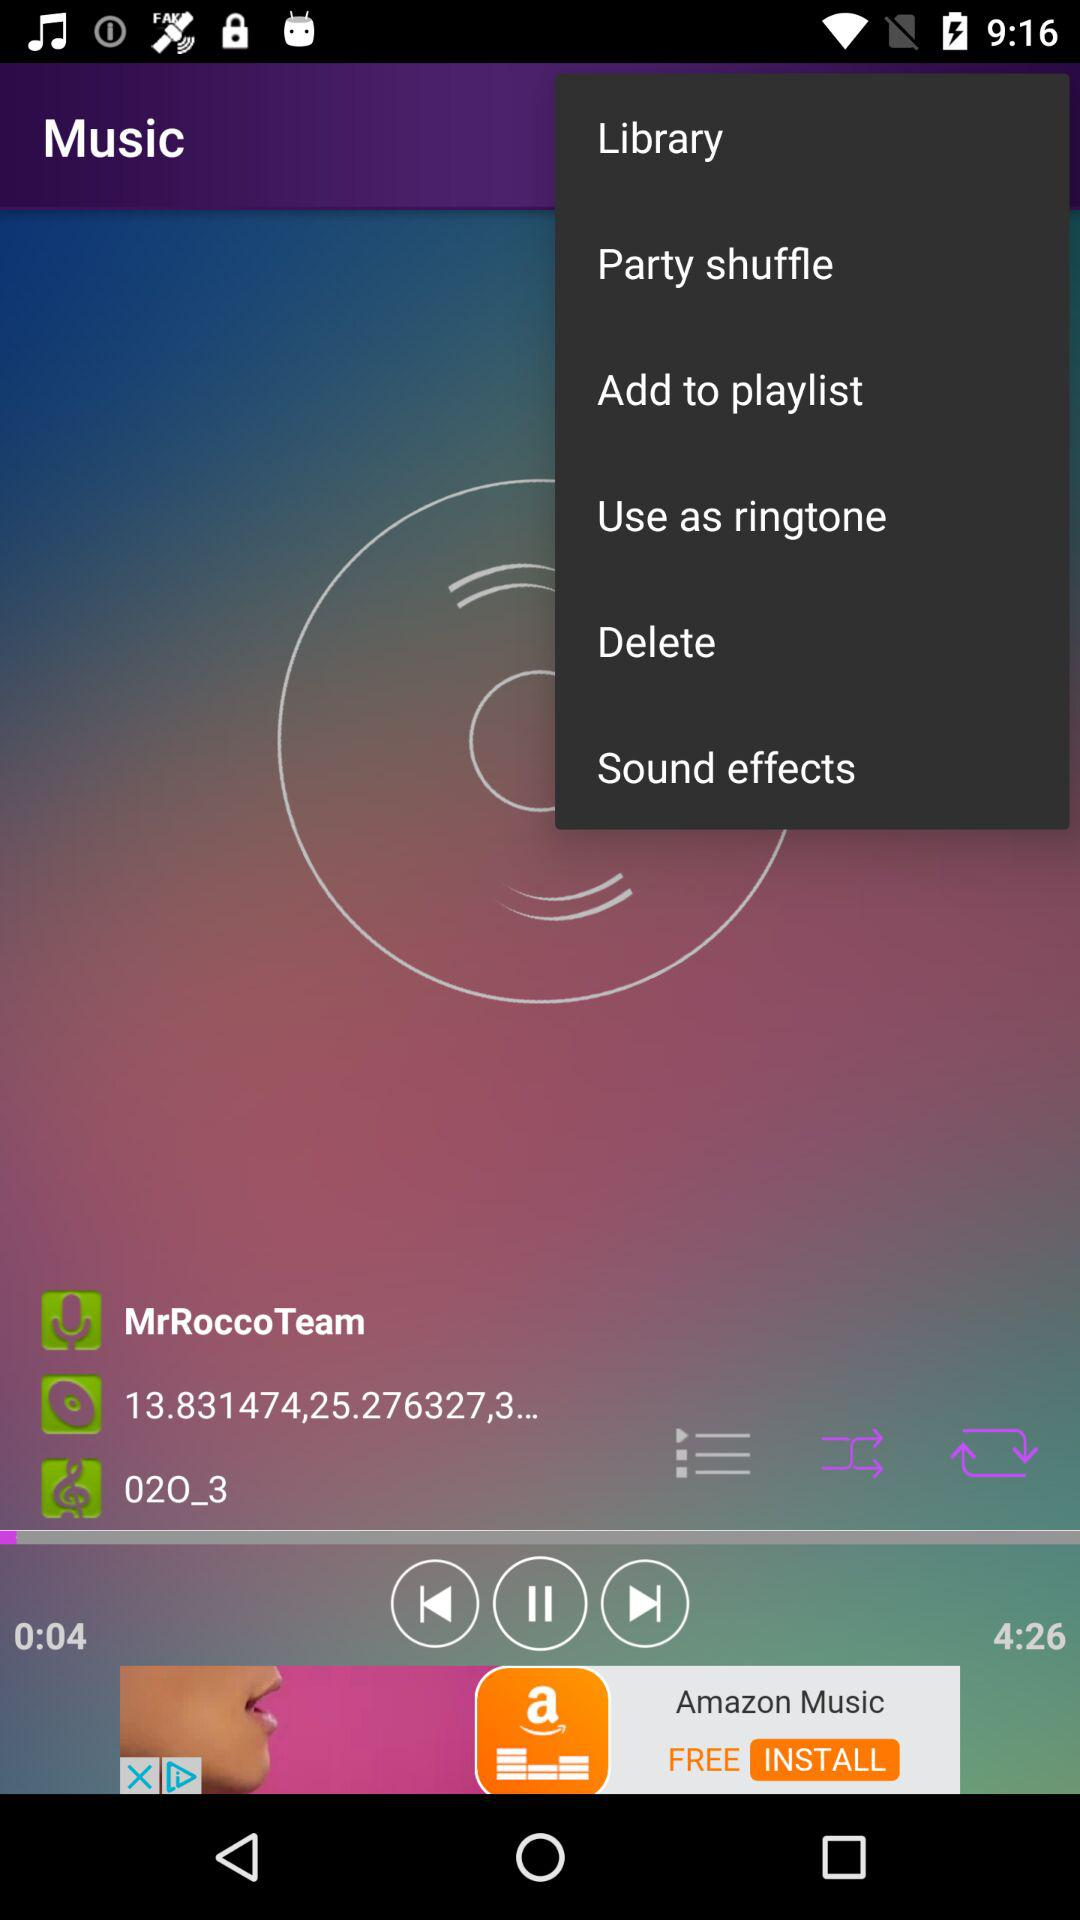Which song is playing on the screen? The song playing on the screen is "02O_3". 